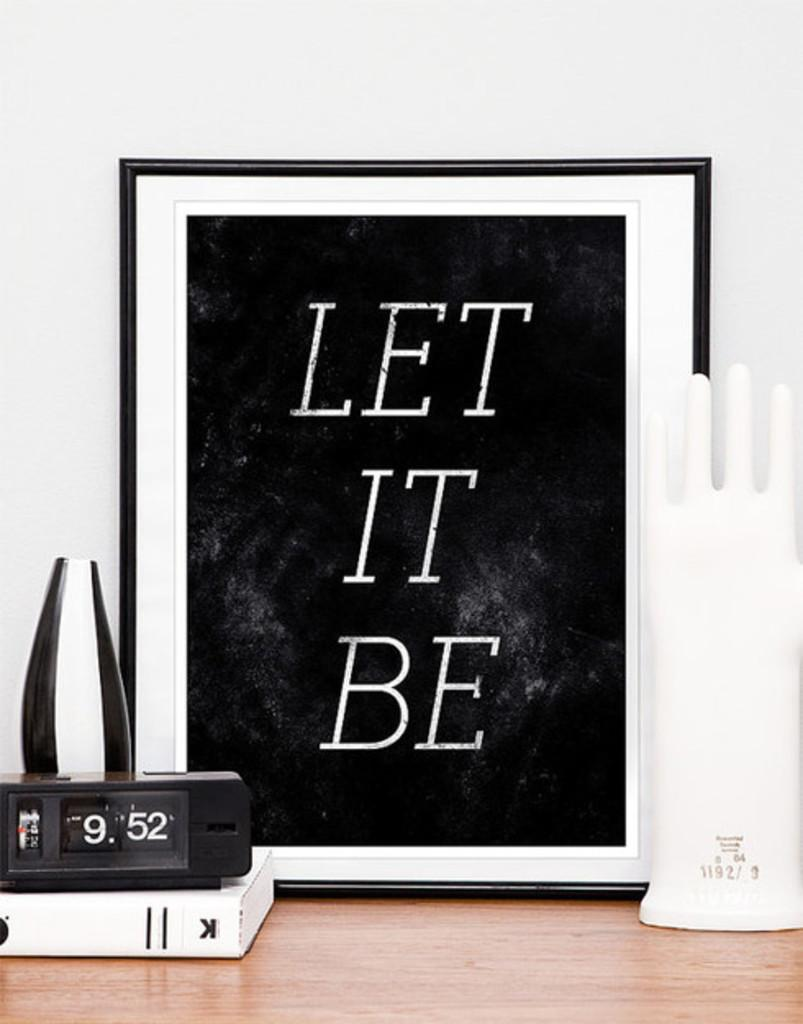<image>
Share a concise interpretation of the image provided. A Let It Be poster is framed in a black frame. 